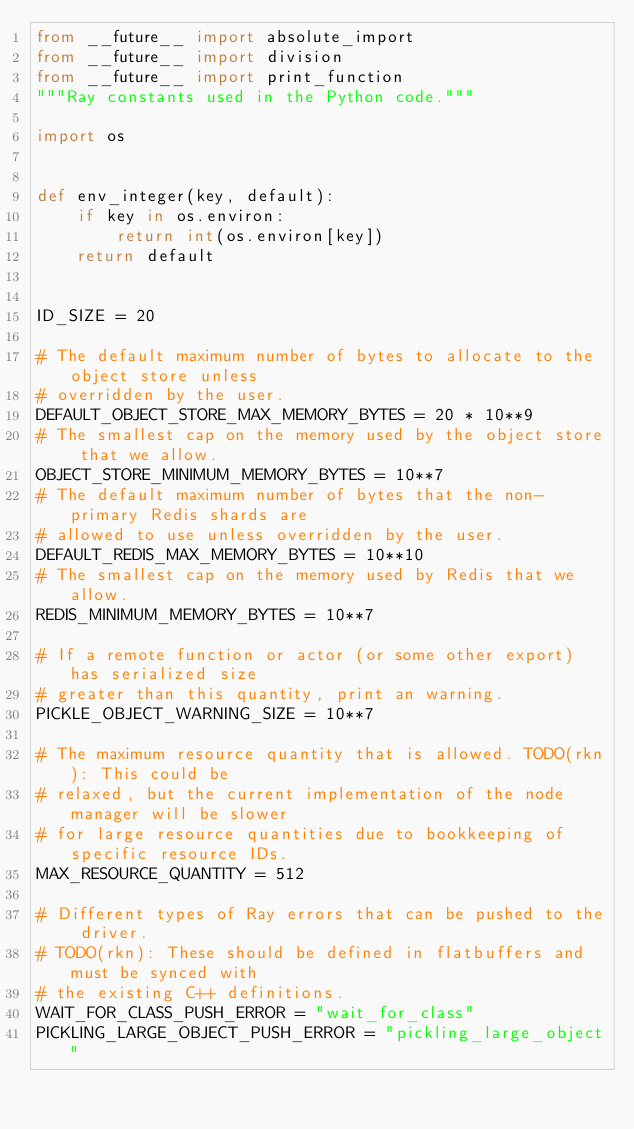<code> <loc_0><loc_0><loc_500><loc_500><_Python_>from __future__ import absolute_import
from __future__ import division
from __future__ import print_function
"""Ray constants used in the Python code."""

import os


def env_integer(key, default):
    if key in os.environ:
        return int(os.environ[key])
    return default


ID_SIZE = 20

# The default maximum number of bytes to allocate to the object store unless
# overridden by the user.
DEFAULT_OBJECT_STORE_MAX_MEMORY_BYTES = 20 * 10**9
# The smallest cap on the memory used by the object store that we allow.
OBJECT_STORE_MINIMUM_MEMORY_BYTES = 10**7
# The default maximum number of bytes that the non-primary Redis shards are
# allowed to use unless overridden by the user.
DEFAULT_REDIS_MAX_MEMORY_BYTES = 10**10
# The smallest cap on the memory used by Redis that we allow.
REDIS_MINIMUM_MEMORY_BYTES = 10**7

# If a remote function or actor (or some other export) has serialized size
# greater than this quantity, print an warning.
PICKLE_OBJECT_WARNING_SIZE = 10**7

# The maximum resource quantity that is allowed. TODO(rkn): This could be
# relaxed, but the current implementation of the node manager will be slower
# for large resource quantities due to bookkeeping of specific resource IDs.
MAX_RESOURCE_QUANTITY = 512

# Different types of Ray errors that can be pushed to the driver.
# TODO(rkn): These should be defined in flatbuffers and must be synced with
# the existing C++ definitions.
WAIT_FOR_CLASS_PUSH_ERROR = "wait_for_class"
PICKLING_LARGE_OBJECT_PUSH_ERROR = "pickling_large_object"</code> 